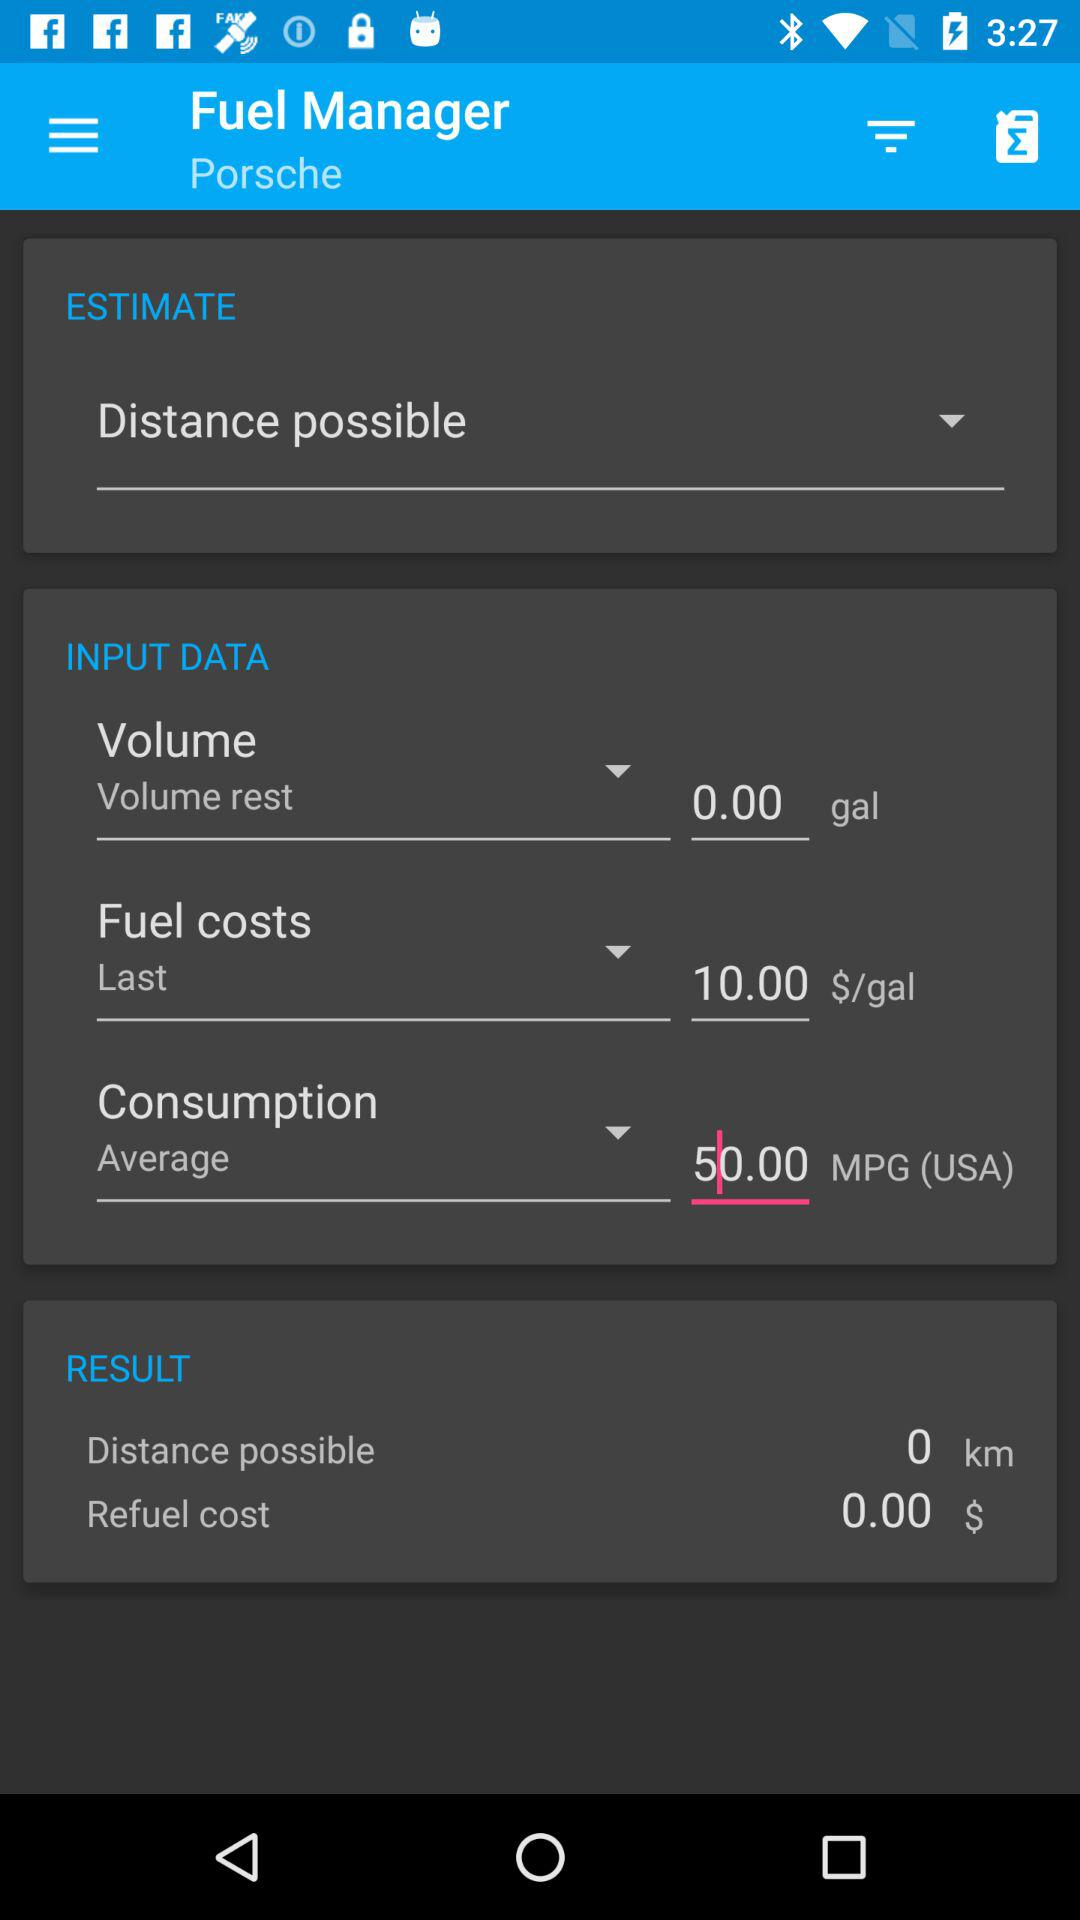What is the fuel cost? The fuel cost is $10.00/gal. 